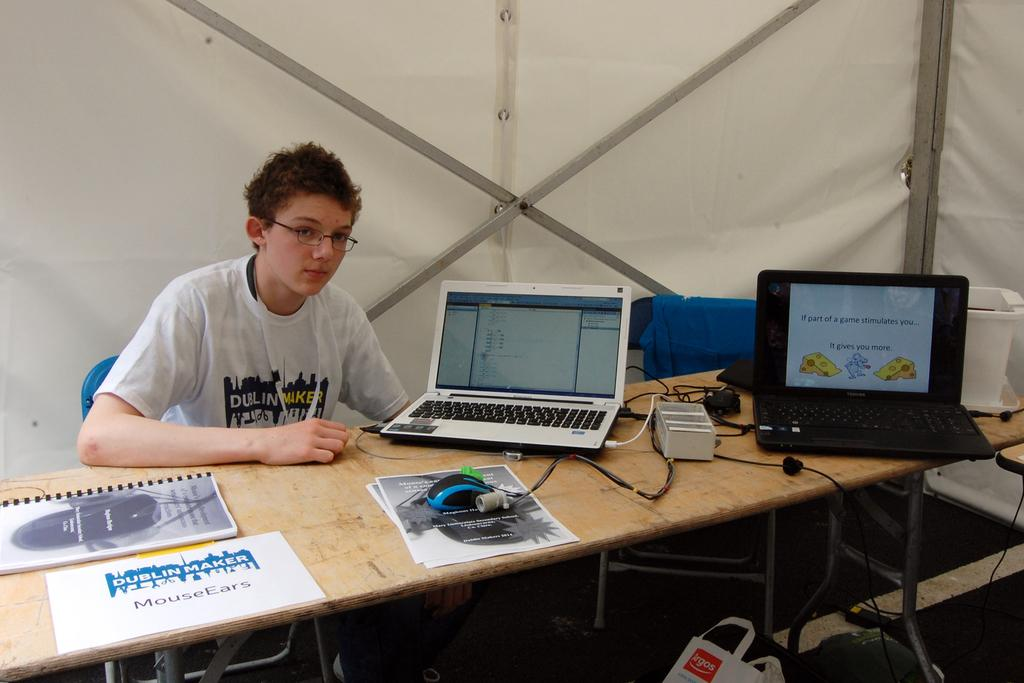<image>
Offer a succinct explanation of the picture presented. Someone wears a Dublin Maker shirt while sitting at a table. 